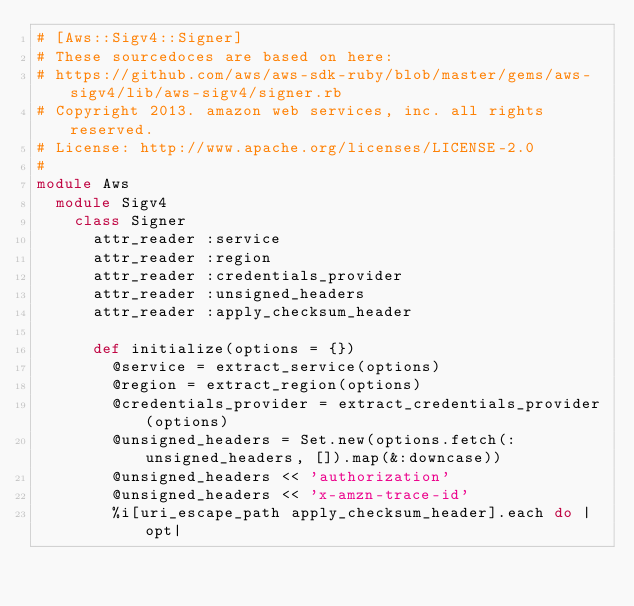Convert code to text. <code><loc_0><loc_0><loc_500><loc_500><_Ruby_># [Aws::Sigv4::Signer]
# These sourcedoces are based on here:
# https://github.com/aws/aws-sdk-ruby/blob/master/gems/aws-sigv4/lib/aws-sigv4/signer.rb
# Copyright 2013. amazon web services, inc. all rights reserved.
# License: http://www.apache.org/licenses/LICENSE-2.0
#
module Aws
  module Sigv4
    class Signer
      attr_reader :service
      attr_reader :region
      attr_reader :credentials_provider
      attr_reader :unsigned_headers
      attr_reader :apply_checksum_header

      def initialize(options = {})
        @service = extract_service(options)
        @region = extract_region(options)
        @credentials_provider = extract_credentials_provider(options)
        @unsigned_headers = Set.new(options.fetch(:unsigned_headers, []).map(&:downcase))
        @unsigned_headers << 'authorization'
        @unsigned_headers << 'x-amzn-trace-id'
        %i[uri_escape_path apply_checksum_header].each do |opt|</code> 